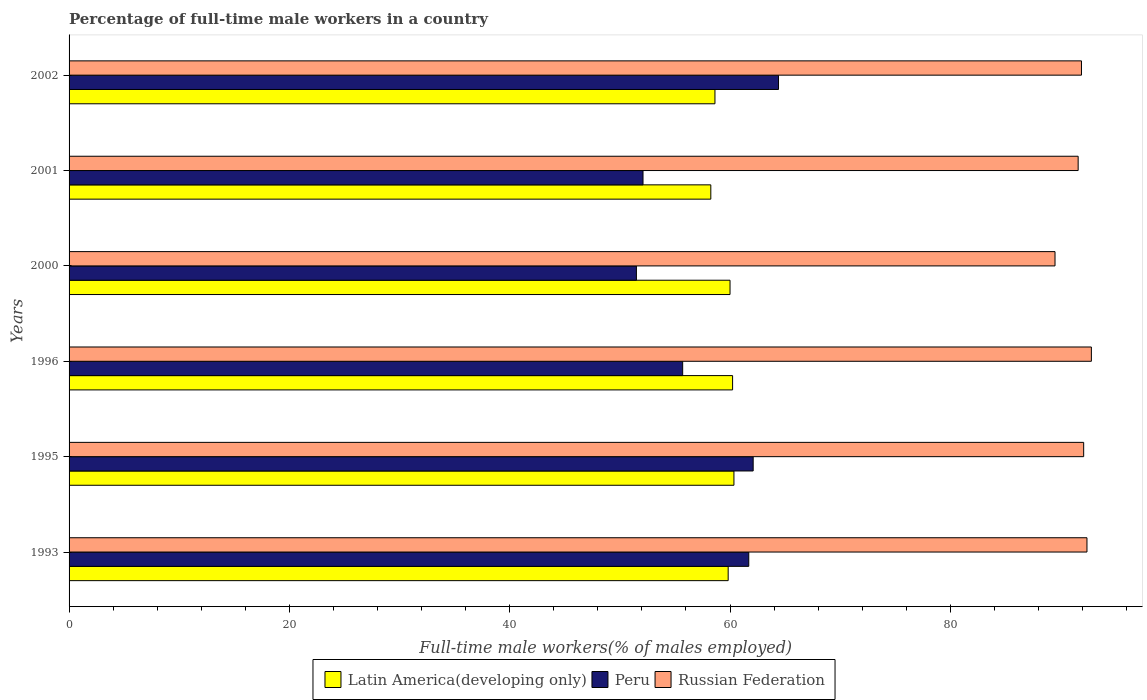Are the number of bars on each tick of the Y-axis equal?
Provide a succinct answer. Yes. In how many cases, is the number of bars for a given year not equal to the number of legend labels?
Make the answer very short. 0. What is the percentage of full-time male workers in Russian Federation in 2001?
Keep it short and to the point. 91.6. Across all years, what is the maximum percentage of full-time male workers in Russian Federation?
Your response must be concise. 92.8. Across all years, what is the minimum percentage of full-time male workers in Peru?
Your answer should be compact. 51.5. In which year was the percentage of full-time male workers in Latin America(developing only) maximum?
Keep it short and to the point. 1995. In which year was the percentage of full-time male workers in Peru minimum?
Offer a very short reply. 2000. What is the total percentage of full-time male workers in Russian Federation in the graph?
Your answer should be compact. 550.3. What is the difference between the percentage of full-time male workers in Peru in 1996 and that in 2000?
Your answer should be very brief. 4.2. What is the difference between the percentage of full-time male workers in Russian Federation in 1993 and the percentage of full-time male workers in Peru in 1995?
Provide a short and direct response. 30.3. What is the average percentage of full-time male workers in Latin America(developing only) per year?
Provide a succinct answer. 59.55. In the year 2001, what is the difference between the percentage of full-time male workers in Latin America(developing only) and percentage of full-time male workers in Peru?
Offer a very short reply. 6.15. What is the ratio of the percentage of full-time male workers in Peru in 1993 to that in 2002?
Your response must be concise. 0.96. Is the percentage of full-time male workers in Russian Federation in 1993 less than that in 2002?
Keep it short and to the point. No. Is the difference between the percentage of full-time male workers in Latin America(developing only) in 2000 and 2002 greater than the difference between the percentage of full-time male workers in Peru in 2000 and 2002?
Your response must be concise. Yes. What is the difference between the highest and the second highest percentage of full-time male workers in Russian Federation?
Provide a short and direct response. 0.4. What is the difference between the highest and the lowest percentage of full-time male workers in Peru?
Ensure brevity in your answer.  12.9. What does the 2nd bar from the top in 1996 represents?
Your response must be concise. Peru. What does the 2nd bar from the bottom in 2000 represents?
Offer a very short reply. Peru. Are all the bars in the graph horizontal?
Provide a succinct answer. Yes. Are the values on the major ticks of X-axis written in scientific E-notation?
Give a very brief answer. No. Does the graph contain any zero values?
Make the answer very short. No. Where does the legend appear in the graph?
Make the answer very short. Bottom center. What is the title of the graph?
Offer a very short reply. Percentage of full-time male workers in a country. What is the label or title of the X-axis?
Your answer should be very brief. Full-time male workers(% of males employed). What is the Full-time male workers(% of males employed) of Latin America(developing only) in 1993?
Provide a short and direct response. 59.83. What is the Full-time male workers(% of males employed) of Peru in 1993?
Provide a short and direct response. 61.7. What is the Full-time male workers(% of males employed) of Russian Federation in 1993?
Provide a succinct answer. 92.4. What is the Full-time male workers(% of males employed) in Latin America(developing only) in 1995?
Your answer should be very brief. 60.35. What is the Full-time male workers(% of males employed) of Peru in 1995?
Your response must be concise. 62.1. What is the Full-time male workers(% of males employed) of Russian Federation in 1995?
Your response must be concise. 92.1. What is the Full-time male workers(% of males employed) in Latin America(developing only) in 1996?
Offer a very short reply. 60.23. What is the Full-time male workers(% of males employed) of Peru in 1996?
Provide a succinct answer. 55.7. What is the Full-time male workers(% of males employed) of Russian Federation in 1996?
Provide a short and direct response. 92.8. What is the Full-time male workers(% of males employed) of Latin America(developing only) in 2000?
Offer a terse response. 60. What is the Full-time male workers(% of males employed) in Peru in 2000?
Your response must be concise. 51.5. What is the Full-time male workers(% of males employed) of Russian Federation in 2000?
Provide a succinct answer. 89.5. What is the Full-time male workers(% of males employed) of Latin America(developing only) in 2001?
Your response must be concise. 58.25. What is the Full-time male workers(% of males employed) in Peru in 2001?
Give a very brief answer. 52.1. What is the Full-time male workers(% of males employed) in Russian Federation in 2001?
Ensure brevity in your answer.  91.6. What is the Full-time male workers(% of males employed) in Latin America(developing only) in 2002?
Give a very brief answer. 58.63. What is the Full-time male workers(% of males employed) of Peru in 2002?
Offer a terse response. 64.4. What is the Full-time male workers(% of males employed) in Russian Federation in 2002?
Your response must be concise. 91.9. Across all years, what is the maximum Full-time male workers(% of males employed) of Latin America(developing only)?
Offer a very short reply. 60.35. Across all years, what is the maximum Full-time male workers(% of males employed) of Peru?
Offer a very short reply. 64.4. Across all years, what is the maximum Full-time male workers(% of males employed) of Russian Federation?
Offer a terse response. 92.8. Across all years, what is the minimum Full-time male workers(% of males employed) in Latin America(developing only)?
Offer a terse response. 58.25. Across all years, what is the minimum Full-time male workers(% of males employed) in Peru?
Offer a very short reply. 51.5. Across all years, what is the minimum Full-time male workers(% of males employed) in Russian Federation?
Provide a short and direct response. 89.5. What is the total Full-time male workers(% of males employed) of Latin America(developing only) in the graph?
Ensure brevity in your answer.  357.3. What is the total Full-time male workers(% of males employed) of Peru in the graph?
Your response must be concise. 347.5. What is the total Full-time male workers(% of males employed) of Russian Federation in the graph?
Keep it short and to the point. 550.3. What is the difference between the Full-time male workers(% of males employed) in Latin America(developing only) in 1993 and that in 1995?
Ensure brevity in your answer.  -0.52. What is the difference between the Full-time male workers(% of males employed) of Peru in 1993 and that in 1995?
Provide a short and direct response. -0.4. What is the difference between the Full-time male workers(% of males employed) of Latin America(developing only) in 1993 and that in 1996?
Your answer should be compact. -0.4. What is the difference between the Full-time male workers(% of males employed) in Russian Federation in 1993 and that in 1996?
Your answer should be very brief. -0.4. What is the difference between the Full-time male workers(% of males employed) of Latin America(developing only) in 1993 and that in 2000?
Offer a terse response. -0.17. What is the difference between the Full-time male workers(% of males employed) of Russian Federation in 1993 and that in 2000?
Offer a very short reply. 2.9. What is the difference between the Full-time male workers(% of males employed) of Latin America(developing only) in 1993 and that in 2001?
Your answer should be compact. 1.58. What is the difference between the Full-time male workers(% of males employed) in Russian Federation in 1993 and that in 2001?
Provide a short and direct response. 0.8. What is the difference between the Full-time male workers(% of males employed) of Latin America(developing only) in 1993 and that in 2002?
Ensure brevity in your answer.  1.2. What is the difference between the Full-time male workers(% of males employed) in Latin America(developing only) in 1995 and that in 1996?
Offer a very short reply. 0.12. What is the difference between the Full-time male workers(% of males employed) in Latin America(developing only) in 1995 and that in 2000?
Keep it short and to the point. 0.35. What is the difference between the Full-time male workers(% of males employed) in Peru in 1995 and that in 2000?
Offer a terse response. 10.6. What is the difference between the Full-time male workers(% of males employed) in Russian Federation in 1995 and that in 2000?
Your answer should be very brief. 2.6. What is the difference between the Full-time male workers(% of males employed) in Latin America(developing only) in 1995 and that in 2001?
Make the answer very short. 2.1. What is the difference between the Full-time male workers(% of males employed) of Peru in 1995 and that in 2001?
Give a very brief answer. 10. What is the difference between the Full-time male workers(% of males employed) of Latin America(developing only) in 1995 and that in 2002?
Offer a very short reply. 1.72. What is the difference between the Full-time male workers(% of males employed) of Peru in 1995 and that in 2002?
Your response must be concise. -2.3. What is the difference between the Full-time male workers(% of males employed) of Latin America(developing only) in 1996 and that in 2000?
Provide a succinct answer. 0.23. What is the difference between the Full-time male workers(% of males employed) in Peru in 1996 and that in 2000?
Your answer should be very brief. 4.2. What is the difference between the Full-time male workers(% of males employed) of Latin America(developing only) in 1996 and that in 2001?
Keep it short and to the point. 1.98. What is the difference between the Full-time male workers(% of males employed) of Peru in 1996 and that in 2001?
Make the answer very short. 3.6. What is the difference between the Full-time male workers(% of males employed) of Russian Federation in 1996 and that in 2001?
Offer a very short reply. 1.2. What is the difference between the Full-time male workers(% of males employed) in Latin America(developing only) in 1996 and that in 2002?
Offer a terse response. 1.6. What is the difference between the Full-time male workers(% of males employed) of Latin America(developing only) in 2000 and that in 2001?
Your answer should be compact. 1.74. What is the difference between the Full-time male workers(% of males employed) in Latin America(developing only) in 2000 and that in 2002?
Keep it short and to the point. 1.37. What is the difference between the Full-time male workers(% of males employed) in Russian Federation in 2000 and that in 2002?
Keep it short and to the point. -2.4. What is the difference between the Full-time male workers(% of males employed) of Latin America(developing only) in 2001 and that in 2002?
Provide a succinct answer. -0.38. What is the difference between the Full-time male workers(% of males employed) of Peru in 2001 and that in 2002?
Provide a succinct answer. -12.3. What is the difference between the Full-time male workers(% of males employed) in Russian Federation in 2001 and that in 2002?
Offer a terse response. -0.3. What is the difference between the Full-time male workers(% of males employed) of Latin America(developing only) in 1993 and the Full-time male workers(% of males employed) of Peru in 1995?
Ensure brevity in your answer.  -2.27. What is the difference between the Full-time male workers(% of males employed) in Latin America(developing only) in 1993 and the Full-time male workers(% of males employed) in Russian Federation in 1995?
Offer a terse response. -32.27. What is the difference between the Full-time male workers(% of males employed) of Peru in 1993 and the Full-time male workers(% of males employed) of Russian Federation in 1995?
Provide a succinct answer. -30.4. What is the difference between the Full-time male workers(% of males employed) in Latin America(developing only) in 1993 and the Full-time male workers(% of males employed) in Peru in 1996?
Provide a short and direct response. 4.13. What is the difference between the Full-time male workers(% of males employed) in Latin America(developing only) in 1993 and the Full-time male workers(% of males employed) in Russian Federation in 1996?
Your answer should be compact. -32.97. What is the difference between the Full-time male workers(% of males employed) in Peru in 1993 and the Full-time male workers(% of males employed) in Russian Federation in 1996?
Your answer should be compact. -31.1. What is the difference between the Full-time male workers(% of males employed) in Latin America(developing only) in 1993 and the Full-time male workers(% of males employed) in Peru in 2000?
Give a very brief answer. 8.33. What is the difference between the Full-time male workers(% of males employed) of Latin America(developing only) in 1993 and the Full-time male workers(% of males employed) of Russian Federation in 2000?
Make the answer very short. -29.67. What is the difference between the Full-time male workers(% of males employed) in Peru in 1993 and the Full-time male workers(% of males employed) in Russian Federation in 2000?
Give a very brief answer. -27.8. What is the difference between the Full-time male workers(% of males employed) of Latin America(developing only) in 1993 and the Full-time male workers(% of males employed) of Peru in 2001?
Your answer should be compact. 7.73. What is the difference between the Full-time male workers(% of males employed) in Latin America(developing only) in 1993 and the Full-time male workers(% of males employed) in Russian Federation in 2001?
Offer a terse response. -31.77. What is the difference between the Full-time male workers(% of males employed) in Peru in 1993 and the Full-time male workers(% of males employed) in Russian Federation in 2001?
Your answer should be very brief. -29.9. What is the difference between the Full-time male workers(% of males employed) in Latin America(developing only) in 1993 and the Full-time male workers(% of males employed) in Peru in 2002?
Provide a succinct answer. -4.57. What is the difference between the Full-time male workers(% of males employed) of Latin America(developing only) in 1993 and the Full-time male workers(% of males employed) of Russian Federation in 2002?
Keep it short and to the point. -32.07. What is the difference between the Full-time male workers(% of males employed) of Peru in 1993 and the Full-time male workers(% of males employed) of Russian Federation in 2002?
Make the answer very short. -30.2. What is the difference between the Full-time male workers(% of males employed) in Latin America(developing only) in 1995 and the Full-time male workers(% of males employed) in Peru in 1996?
Offer a very short reply. 4.65. What is the difference between the Full-time male workers(% of males employed) of Latin America(developing only) in 1995 and the Full-time male workers(% of males employed) of Russian Federation in 1996?
Your answer should be compact. -32.45. What is the difference between the Full-time male workers(% of males employed) of Peru in 1995 and the Full-time male workers(% of males employed) of Russian Federation in 1996?
Offer a very short reply. -30.7. What is the difference between the Full-time male workers(% of males employed) in Latin America(developing only) in 1995 and the Full-time male workers(% of males employed) in Peru in 2000?
Keep it short and to the point. 8.85. What is the difference between the Full-time male workers(% of males employed) in Latin America(developing only) in 1995 and the Full-time male workers(% of males employed) in Russian Federation in 2000?
Provide a succinct answer. -29.15. What is the difference between the Full-time male workers(% of males employed) of Peru in 1995 and the Full-time male workers(% of males employed) of Russian Federation in 2000?
Your answer should be very brief. -27.4. What is the difference between the Full-time male workers(% of males employed) of Latin America(developing only) in 1995 and the Full-time male workers(% of males employed) of Peru in 2001?
Make the answer very short. 8.25. What is the difference between the Full-time male workers(% of males employed) of Latin America(developing only) in 1995 and the Full-time male workers(% of males employed) of Russian Federation in 2001?
Ensure brevity in your answer.  -31.25. What is the difference between the Full-time male workers(% of males employed) in Peru in 1995 and the Full-time male workers(% of males employed) in Russian Federation in 2001?
Your answer should be compact. -29.5. What is the difference between the Full-time male workers(% of males employed) in Latin America(developing only) in 1995 and the Full-time male workers(% of males employed) in Peru in 2002?
Keep it short and to the point. -4.05. What is the difference between the Full-time male workers(% of males employed) in Latin America(developing only) in 1995 and the Full-time male workers(% of males employed) in Russian Federation in 2002?
Provide a short and direct response. -31.55. What is the difference between the Full-time male workers(% of males employed) in Peru in 1995 and the Full-time male workers(% of males employed) in Russian Federation in 2002?
Provide a succinct answer. -29.8. What is the difference between the Full-time male workers(% of males employed) of Latin America(developing only) in 1996 and the Full-time male workers(% of males employed) of Peru in 2000?
Ensure brevity in your answer.  8.73. What is the difference between the Full-time male workers(% of males employed) in Latin America(developing only) in 1996 and the Full-time male workers(% of males employed) in Russian Federation in 2000?
Make the answer very short. -29.27. What is the difference between the Full-time male workers(% of males employed) of Peru in 1996 and the Full-time male workers(% of males employed) of Russian Federation in 2000?
Offer a terse response. -33.8. What is the difference between the Full-time male workers(% of males employed) in Latin America(developing only) in 1996 and the Full-time male workers(% of males employed) in Peru in 2001?
Your answer should be very brief. 8.13. What is the difference between the Full-time male workers(% of males employed) in Latin America(developing only) in 1996 and the Full-time male workers(% of males employed) in Russian Federation in 2001?
Keep it short and to the point. -31.37. What is the difference between the Full-time male workers(% of males employed) in Peru in 1996 and the Full-time male workers(% of males employed) in Russian Federation in 2001?
Offer a very short reply. -35.9. What is the difference between the Full-time male workers(% of males employed) in Latin America(developing only) in 1996 and the Full-time male workers(% of males employed) in Peru in 2002?
Offer a very short reply. -4.17. What is the difference between the Full-time male workers(% of males employed) of Latin America(developing only) in 1996 and the Full-time male workers(% of males employed) of Russian Federation in 2002?
Make the answer very short. -31.67. What is the difference between the Full-time male workers(% of males employed) in Peru in 1996 and the Full-time male workers(% of males employed) in Russian Federation in 2002?
Make the answer very short. -36.2. What is the difference between the Full-time male workers(% of males employed) of Latin America(developing only) in 2000 and the Full-time male workers(% of males employed) of Peru in 2001?
Give a very brief answer. 7.9. What is the difference between the Full-time male workers(% of males employed) of Latin America(developing only) in 2000 and the Full-time male workers(% of males employed) of Russian Federation in 2001?
Provide a short and direct response. -31.6. What is the difference between the Full-time male workers(% of males employed) in Peru in 2000 and the Full-time male workers(% of males employed) in Russian Federation in 2001?
Provide a succinct answer. -40.1. What is the difference between the Full-time male workers(% of males employed) in Latin America(developing only) in 2000 and the Full-time male workers(% of males employed) in Peru in 2002?
Keep it short and to the point. -4.4. What is the difference between the Full-time male workers(% of males employed) of Latin America(developing only) in 2000 and the Full-time male workers(% of males employed) of Russian Federation in 2002?
Offer a terse response. -31.9. What is the difference between the Full-time male workers(% of males employed) of Peru in 2000 and the Full-time male workers(% of males employed) of Russian Federation in 2002?
Give a very brief answer. -40.4. What is the difference between the Full-time male workers(% of males employed) in Latin America(developing only) in 2001 and the Full-time male workers(% of males employed) in Peru in 2002?
Keep it short and to the point. -6.15. What is the difference between the Full-time male workers(% of males employed) of Latin America(developing only) in 2001 and the Full-time male workers(% of males employed) of Russian Federation in 2002?
Make the answer very short. -33.65. What is the difference between the Full-time male workers(% of males employed) in Peru in 2001 and the Full-time male workers(% of males employed) in Russian Federation in 2002?
Your answer should be very brief. -39.8. What is the average Full-time male workers(% of males employed) in Latin America(developing only) per year?
Keep it short and to the point. 59.55. What is the average Full-time male workers(% of males employed) of Peru per year?
Make the answer very short. 57.92. What is the average Full-time male workers(% of males employed) of Russian Federation per year?
Provide a succinct answer. 91.72. In the year 1993, what is the difference between the Full-time male workers(% of males employed) in Latin America(developing only) and Full-time male workers(% of males employed) in Peru?
Make the answer very short. -1.87. In the year 1993, what is the difference between the Full-time male workers(% of males employed) of Latin America(developing only) and Full-time male workers(% of males employed) of Russian Federation?
Offer a very short reply. -32.57. In the year 1993, what is the difference between the Full-time male workers(% of males employed) in Peru and Full-time male workers(% of males employed) in Russian Federation?
Give a very brief answer. -30.7. In the year 1995, what is the difference between the Full-time male workers(% of males employed) in Latin America(developing only) and Full-time male workers(% of males employed) in Peru?
Your answer should be compact. -1.75. In the year 1995, what is the difference between the Full-time male workers(% of males employed) of Latin America(developing only) and Full-time male workers(% of males employed) of Russian Federation?
Offer a very short reply. -31.75. In the year 1995, what is the difference between the Full-time male workers(% of males employed) in Peru and Full-time male workers(% of males employed) in Russian Federation?
Make the answer very short. -30. In the year 1996, what is the difference between the Full-time male workers(% of males employed) of Latin America(developing only) and Full-time male workers(% of males employed) of Peru?
Ensure brevity in your answer.  4.53. In the year 1996, what is the difference between the Full-time male workers(% of males employed) in Latin America(developing only) and Full-time male workers(% of males employed) in Russian Federation?
Ensure brevity in your answer.  -32.57. In the year 1996, what is the difference between the Full-time male workers(% of males employed) in Peru and Full-time male workers(% of males employed) in Russian Federation?
Give a very brief answer. -37.1. In the year 2000, what is the difference between the Full-time male workers(% of males employed) in Latin America(developing only) and Full-time male workers(% of males employed) in Peru?
Keep it short and to the point. 8.5. In the year 2000, what is the difference between the Full-time male workers(% of males employed) in Latin America(developing only) and Full-time male workers(% of males employed) in Russian Federation?
Your response must be concise. -29.5. In the year 2000, what is the difference between the Full-time male workers(% of males employed) in Peru and Full-time male workers(% of males employed) in Russian Federation?
Give a very brief answer. -38. In the year 2001, what is the difference between the Full-time male workers(% of males employed) of Latin America(developing only) and Full-time male workers(% of males employed) of Peru?
Provide a short and direct response. 6.15. In the year 2001, what is the difference between the Full-time male workers(% of males employed) in Latin America(developing only) and Full-time male workers(% of males employed) in Russian Federation?
Your answer should be compact. -33.35. In the year 2001, what is the difference between the Full-time male workers(% of males employed) in Peru and Full-time male workers(% of males employed) in Russian Federation?
Your response must be concise. -39.5. In the year 2002, what is the difference between the Full-time male workers(% of males employed) in Latin America(developing only) and Full-time male workers(% of males employed) in Peru?
Your response must be concise. -5.77. In the year 2002, what is the difference between the Full-time male workers(% of males employed) of Latin America(developing only) and Full-time male workers(% of males employed) of Russian Federation?
Your response must be concise. -33.27. In the year 2002, what is the difference between the Full-time male workers(% of males employed) of Peru and Full-time male workers(% of males employed) of Russian Federation?
Make the answer very short. -27.5. What is the ratio of the Full-time male workers(% of males employed) in Latin America(developing only) in 1993 to that in 1995?
Keep it short and to the point. 0.99. What is the ratio of the Full-time male workers(% of males employed) in Peru in 1993 to that in 1995?
Make the answer very short. 0.99. What is the ratio of the Full-time male workers(% of males employed) in Peru in 1993 to that in 1996?
Offer a terse response. 1.11. What is the ratio of the Full-time male workers(% of males employed) in Russian Federation in 1993 to that in 1996?
Provide a succinct answer. 1. What is the ratio of the Full-time male workers(% of males employed) in Peru in 1993 to that in 2000?
Offer a terse response. 1.2. What is the ratio of the Full-time male workers(% of males employed) of Russian Federation in 1993 to that in 2000?
Make the answer very short. 1.03. What is the ratio of the Full-time male workers(% of males employed) in Latin America(developing only) in 1993 to that in 2001?
Provide a short and direct response. 1.03. What is the ratio of the Full-time male workers(% of males employed) in Peru in 1993 to that in 2001?
Ensure brevity in your answer.  1.18. What is the ratio of the Full-time male workers(% of males employed) of Russian Federation in 1993 to that in 2001?
Provide a succinct answer. 1.01. What is the ratio of the Full-time male workers(% of males employed) of Latin America(developing only) in 1993 to that in 2002?
Offer a terse response. 1.02. What is the ratio of the Full-time male workers(% of males employed) in Peru in 1993 to that in 2002?
Your answer should be compact. 0.96. What is the ratio of the Full-time male workers(% of males employed) of Russian Federation in 1993 to that in 2002?
Give a very brief answer. 1.01. What is the ratio of the Full-time male workers(% of males employed) of Latin America(developing only) in 1995 to that in 1996?
Keep it short and to the point. 1. What is the ratio of the Full-time male workers(% of males employed) of Peru in 1995 to that in 1996?
Your answer should be very brief. 1.11. What is the ratio of the Full-time male workers(% of males employed) in Latin America(developing only) in 1995 to that in 2000?
Ensure brevity in your answer.  1.01. What is the ratio of the Full-time male workers(% of males employed) in Peru in 1995 to that in 2000?
Your answer should be compact. 1.21. What is the ratio of the Full-time male workers(% of males employed) in Russian Federation in 1995 to that in 2000?
Provide a short and direct response. 1.03. What is the ratio of the Full-time male workers(% of males employed) of Latin America(developing only) in 1995 to that in 2001?
Offer a very short reply. 1.04. What is the ratio of the Full-time male workers(% of males employed) in Peru in 1995 to that in 2001?
Your answer should be very brief. 1.19. What is the ratio of the Full-time male workers(% of males employed) of Latin America(developing only) in 1995 to that in 2002?
Make the answer very short. 1.03. What is the ratio of the Full-time male workers(% of males employed) in Latin America(developing only) in 1996 to that in 2000?
Offer a very short reply. 1. What is the ratio of the Full-time male workers(% of males employed) in Peru in 1996 to that in 2000?
Your answer should be compact. 1.08. What is the ratio of the Full-time male workers(% of males employed) in Russian Federation in 1996 to that in 2000?
Provide a short and direct response. 1.04. What is the ratio of the Full-time male workers(% of males employed) of Latin America(developing only) in 1996 to that in 2001?
Provide a short and direct response. 1.03. What is the ratio of the Full-time male workers(% of males employed) in Peru in 1996 to that in 2001?
Your answer should be very brief. 1.07. What is the ratio of the Full-time male workers(% of males employed) in Russian Federation in 1996 to that in 2001?
Offer a very short reply. 1.01. What is the ratio of the Full-time male workers(% of males employed) in Latin America(developing only) in 1996 to that in 2002?
Your response must be concise. 1.03. What is the ratio of the Full-time male workers(% of males employed) in Peru in 1996 to that in 2002?
Make the answer very short. 0.86. What is the ratio of the Full-time male workers(% of males employed) of Russian Federation in 1996 to that in 2002?
Make the answer very short. 1.01. What is the ratio of the Full-time male workers(% of males employed) in Latin America(developing only) in 2000 to that in 2001?
Provide a short and direct response. 1.03. What is the ratio of the Full-time male workers(% of males employed) in Peru in 2000 to that in 2001?
Offer a terse response. 0.99. What is the ratio of the Full-time male workers(% of males employed) in Russian Federation in 2000 to that in 2001?
Your response must be concise. 0.98. What is the ratio of the Full-time male workers(% of males employed) in Latin America(developing only) in 2000 to that in 2002?
Provide a succinct answer. 1.02. What is the ratio of the Full-time male workers(% of males employed) of Peru in 2000 to that in 2002?
Provide a short and direct response. 0.8. What is the ratio of the Full-time male workers(% of males employed) in Russian Federation in 2000 to that in 2002?
Your response must be concise. 0.97. What is the ratio of the Full-time male workers(% of males employed) in Latin America(developing only) in 2001 to that in 2002?
Offer a very short reply. 0.99. What is the ratio of the Full-time male workers(% of males employed) in Peru in 2001 to that in 2002?
Ensure brevity in your answer.  0.81. What is the ratio of the Full-time male workers(% of males employed) in Russian Federation in 2001 to that in 2002?
Offer a terse response. 1. What is the difference between the highest and the second highest Full-time male workers(% of males employed) of Latin America(developing only)?
Ensure brevity in your answer.  0.12. What is the difference between the highest and the second highest Full-time male workers(% of males employed) of Peru?
Provide a succinct answer. 2.3. What is the difference between the highest and the lowest Full-time male workers(% of males employed) of Latin America(developing only)?
Ensure brevity in your answer.  2.1. 